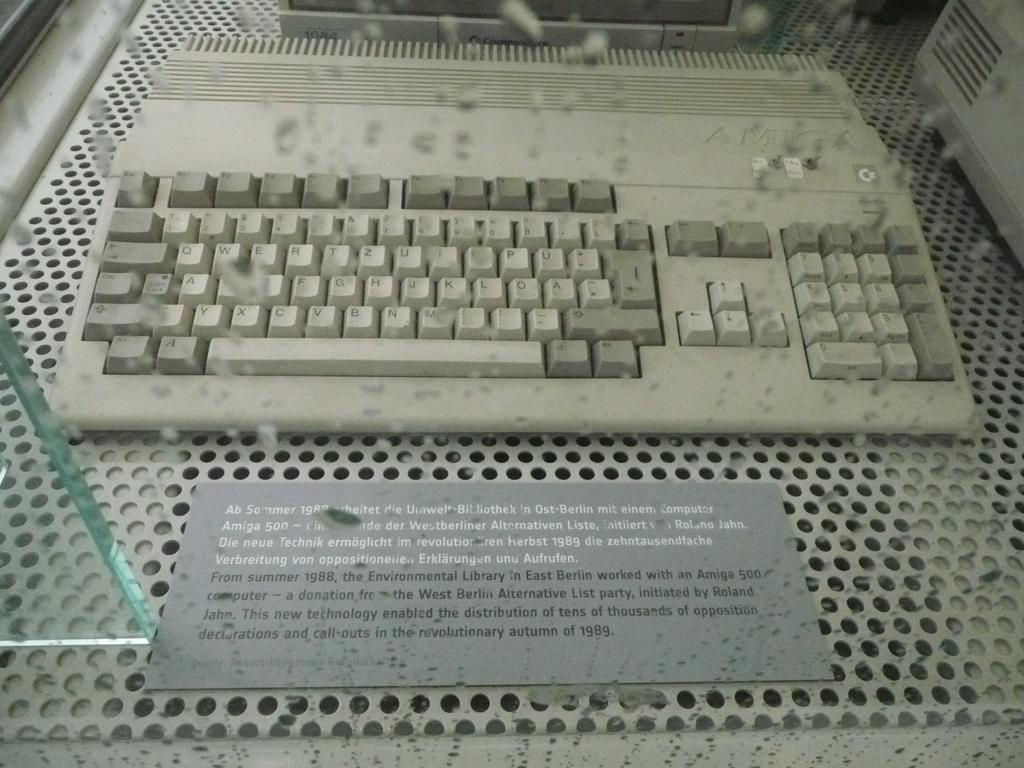<image>
Give a short and clear explanation of the subsequent image. the number 500 is on a sign under a keyboard 